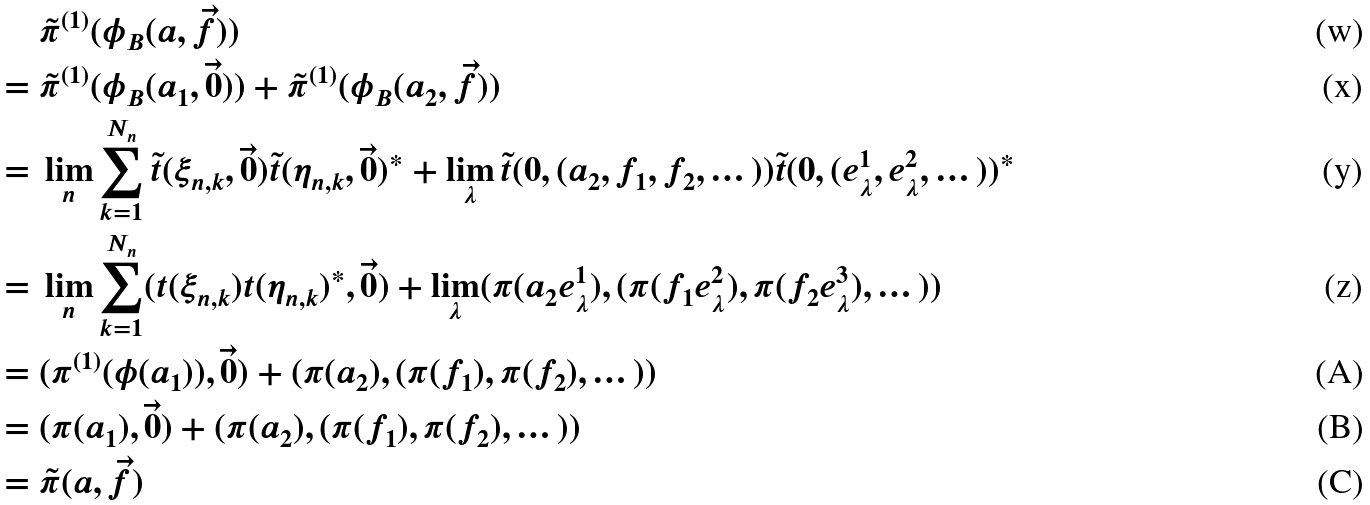Convert formula to latex. <formula><loc_0><loc_0><loc_500><loc_500>& \ \tilde { \pi } ^ { ( 1 ) } ( \phi _ { B } ( a , \vec { f } ) ) \\ = & \ \tilde { \pi } ^ { ( 1 ) } ( \phi _ { B } ( a _ { 1 } , \vec { 0 } ) ) + \tilde { \pi } ^ { ( 1 ) } ( \phi _ { B } ( a _ { 2 } , \vec { f } ) ) \\ = & \ \lim _ { n } \sum _ { k = 1 } ^ { N _ { n } } \tilde { t } ( \xi _ { n , k } , \vec { 0 } ) \tilde { t } ( \eta _ { n , k } , \vec { 0 } ) ^ { * } + \lim _ { \lambda } \tilde { t } ( 0 , ( a _ { 2 } , f _ { 1 } , f _ { 2 } , \dots ) ) \tilde { t } ( 0 , ( e _ { \lambda } ^ { 1 } , e _ { \lambda } ^ { 2 } , \dots ) ) ^ { * } \\ = & \ \lim _ { n } \sum _ { k = 1 } ^ { N _ { n } } ( t ( \xi _ { n , k } ) t ( \eta _ { n , k } ) ^ { * } , \vec { 0 } ) + \lim _ { \lambda } ( \pi ( a _ { 2 } e _ { \lambda } ^ { 1 } ) , ( \pi ( f _ { 1 } e _ { \lambda } ^ { 2 } ) , \pi ( f _ { 2 } e _ { \lambda } ^ { 3 } ) , \dots ) ) \\ = & \ ( \pi ^ { ( 1 ) } ( \phi ( a _ { 1 } ) ) , \vec { 0 } ) + ( \pi ( a _ { 2 } ) , ( \pi ( f _ { 1 } ) , \pi ( f _ { 2 } ) , \dots ) ) \\ = & \ ( \pi ( a _ { 1 } ) , \vec { 0 } ) + ( \pi ( a _ { 2 } ) , ( \pi ( f _ { 1 } ) , \pi ( f _ { 2 } ) , \dots ) ) \\ = & \ \tilde { \pi } ( a , \vec { f } )</formula> 